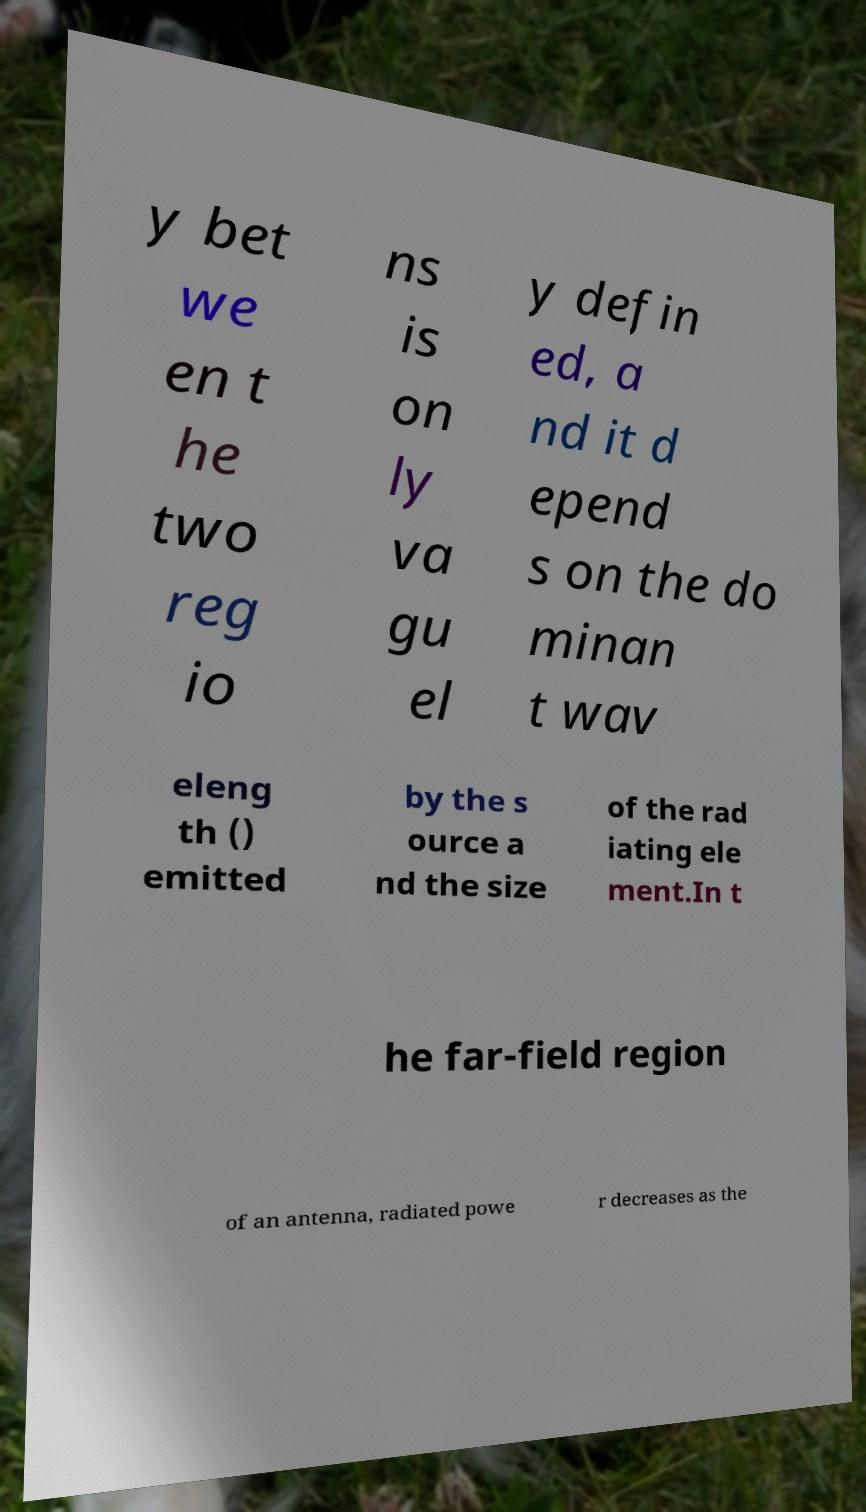Please identify and transcribe the text found in this image. y bet we en t he two reg io ns is on ly va gu el y defin ed, a nd it d epend s on the do minan t wav eleng th () emitted by the s ource a nd the size of the rad iating ele ment.In t he far-field region of an antenna, radiated powe r decreases as the 